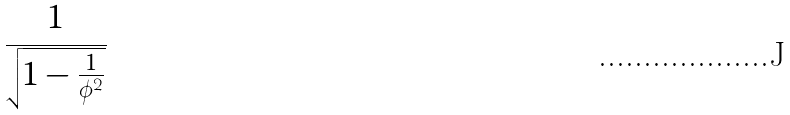<formula> <loc_0><loc_0><loc_500><loc_500>\frac { 1 } { \sqrt { 1 - \frac { 1 } { \phi ^ { 2 } } } }</formula> 